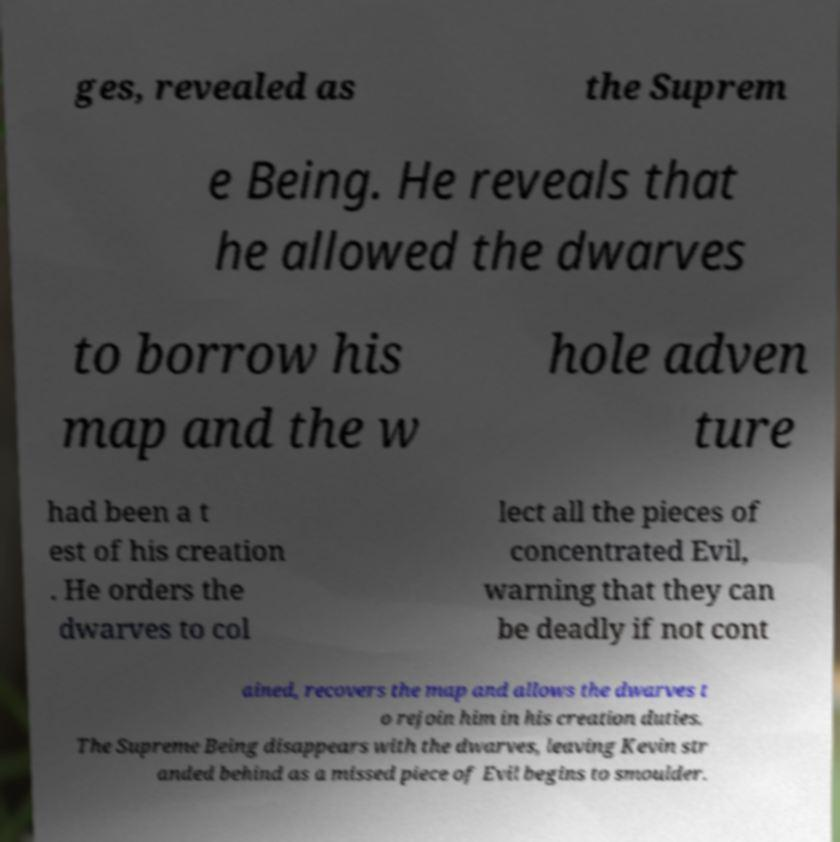What messages or text are displayed in this image? I need them in a readable, typed format. ges, revealed as the Suprem e Being. He reveals that he allowed the dwarves to borrow his map and the w hole adven ture had been a t est of his creation . He orders the dwarves to col lect all the pieces of concentrated Evil, warning that they can be deadly if not cont ained, recovers the map and allows the dwarves t o rejoin him in his creation duties. The Supreme Being disappears with the dwarves, leaving Kevin str anded behind as a missed piece of Evil begins to smoulder. 